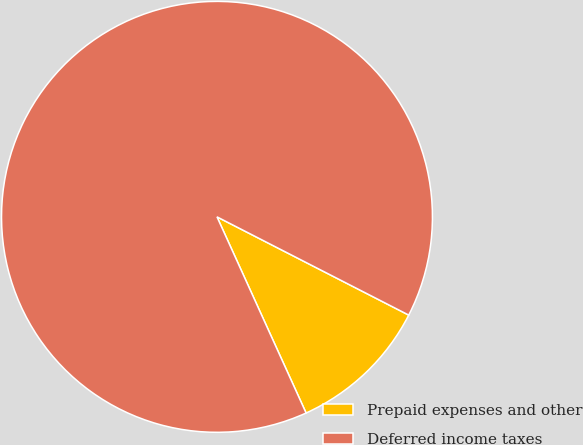Convert chart. <chart><loc_0><loc_0><loc_500><loc_500><pie_chart><fcel>Prepaid expenses and other<fcel>Deferred income taxes<nl><fcel>10.68%<fcel>89.32%<nl></chart> 